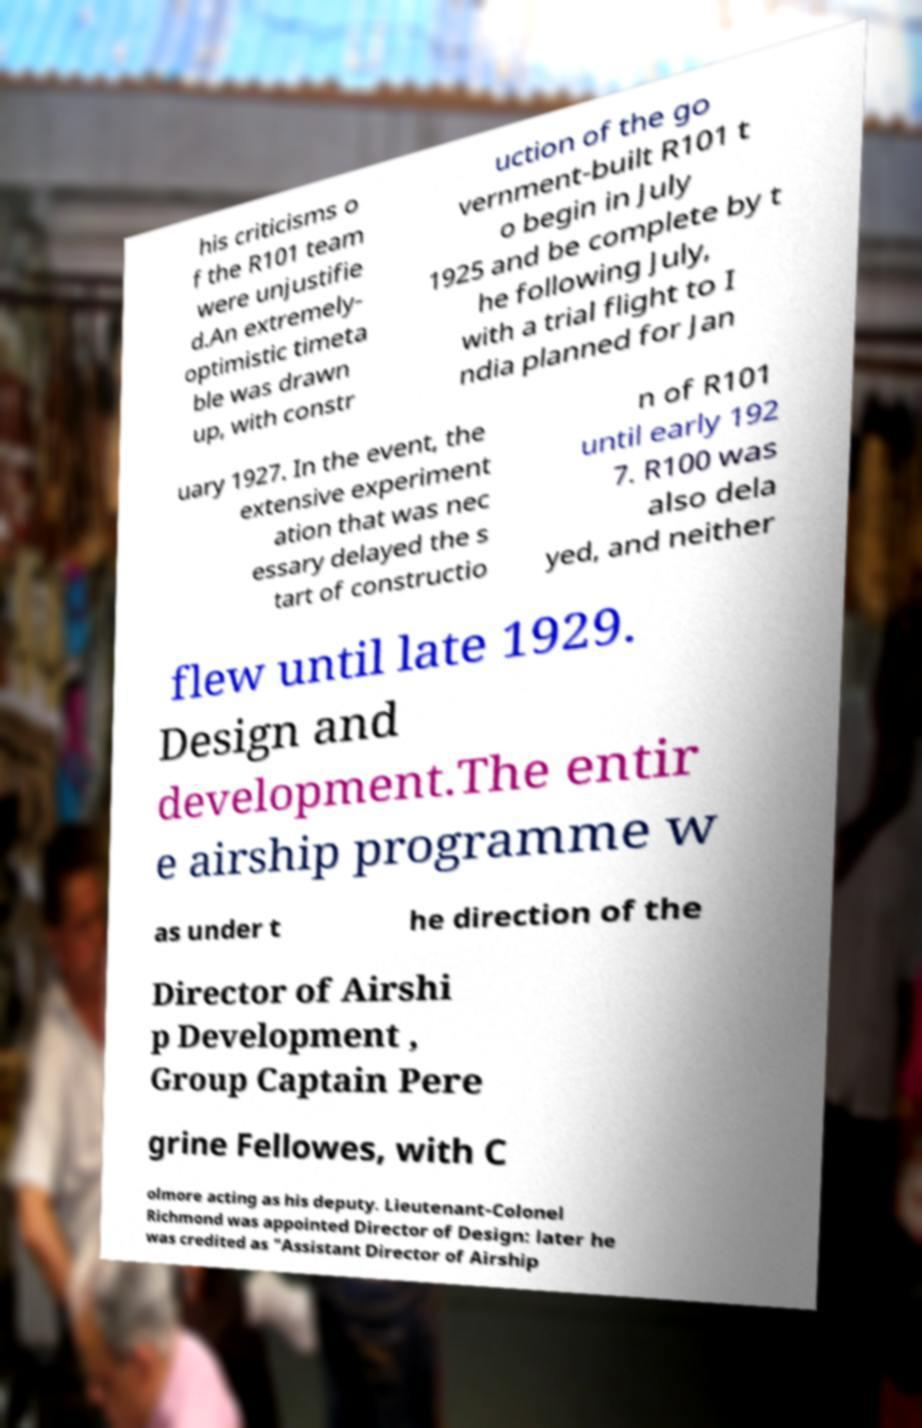Could you assist in decoding the text presented in this image and type it out clearly? his criticisms o f the R101 team were unjustifie d.An extremely- optimistic timeta ble was drawn up, with constr uction of the go vernment-built R101 t o begin in July 1925 and be complete by t he following July, with a trial flight to I ndia planned for Jan uary 1927. In the event, the extensive experiment ation that was nec essary delayed the s tart of constructio n of R101 until early 192 7. R100 was also dela yed, and neither flew until late 1929. Design and development.The entir e airship programme w as under t he direction of the Director of Airshi p Development , Group Captain Pere grine Fellowes, with C olmore acting as his deputy. Lieutenant-Colonel Richmond was appointed Director of Design: later he was credited as "Assistant Director of Airship 